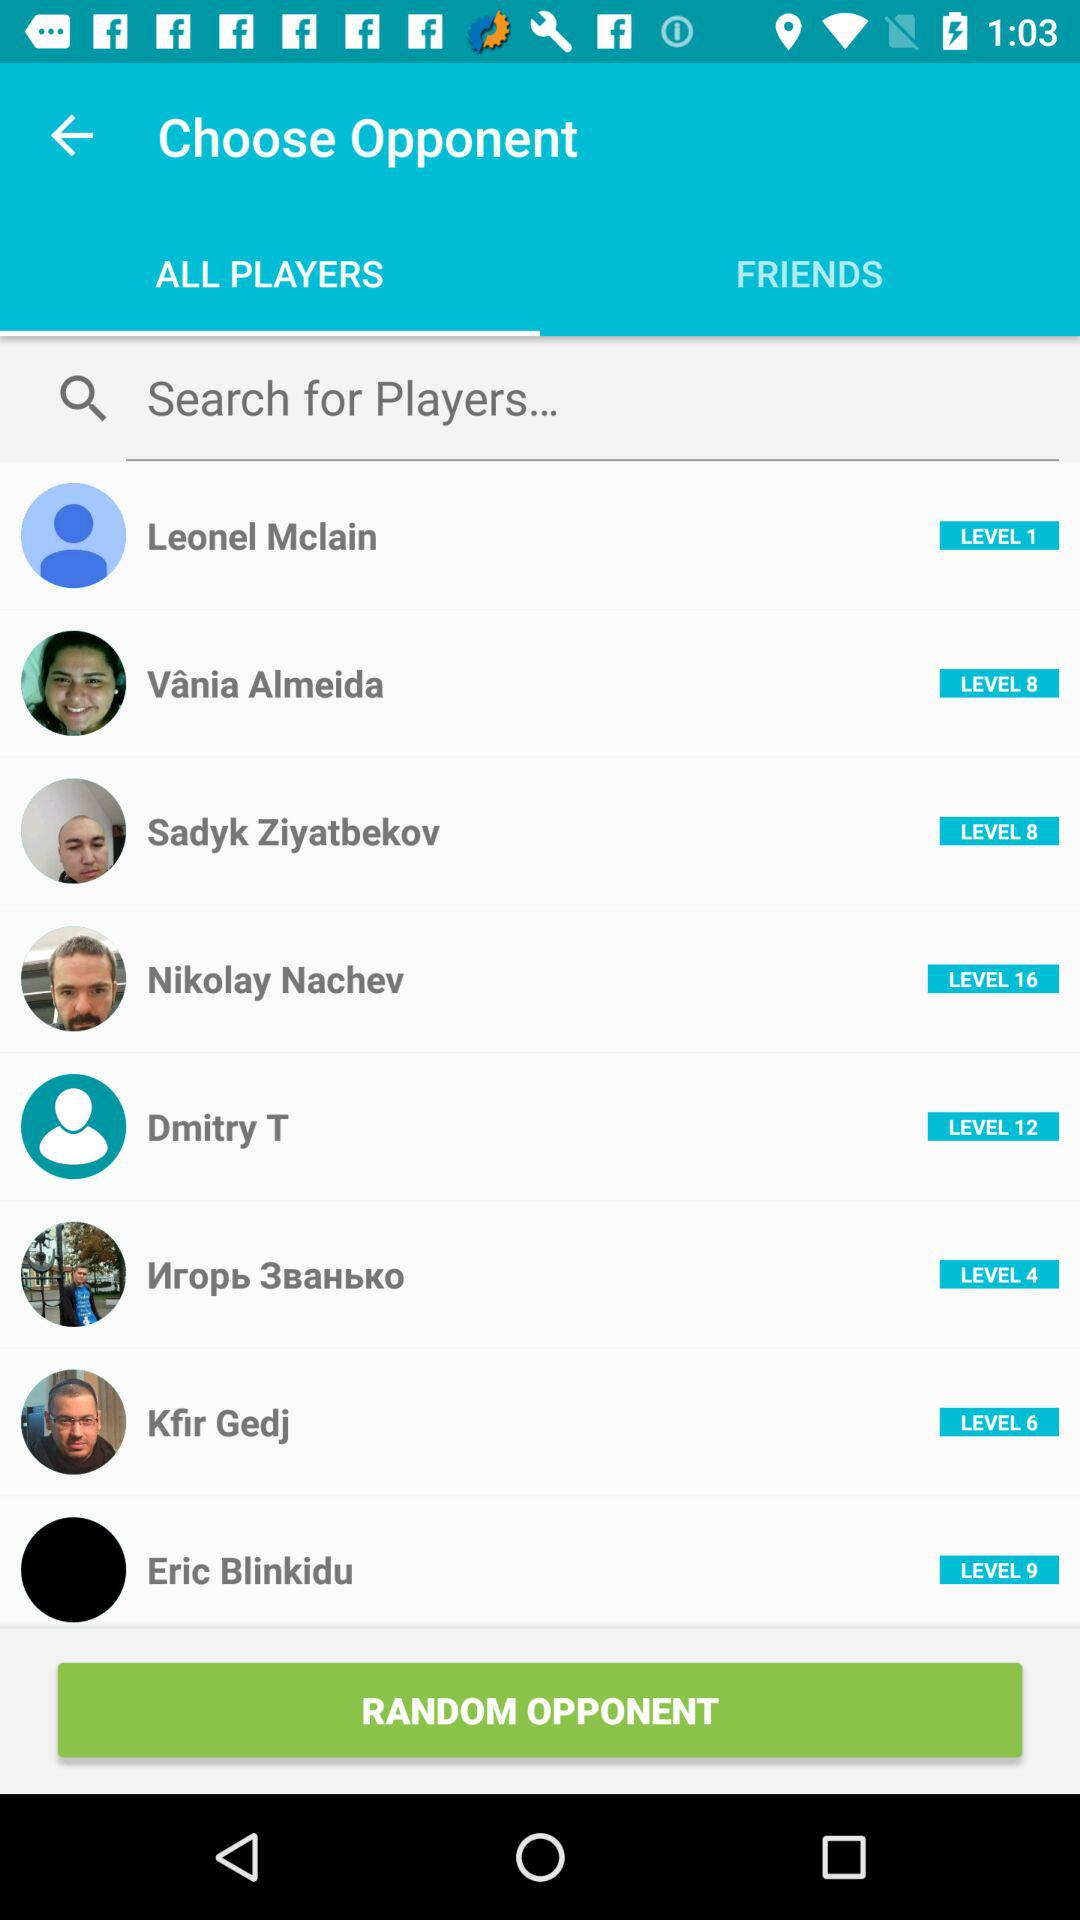What is the level of Dmitry T? The level is 12. 